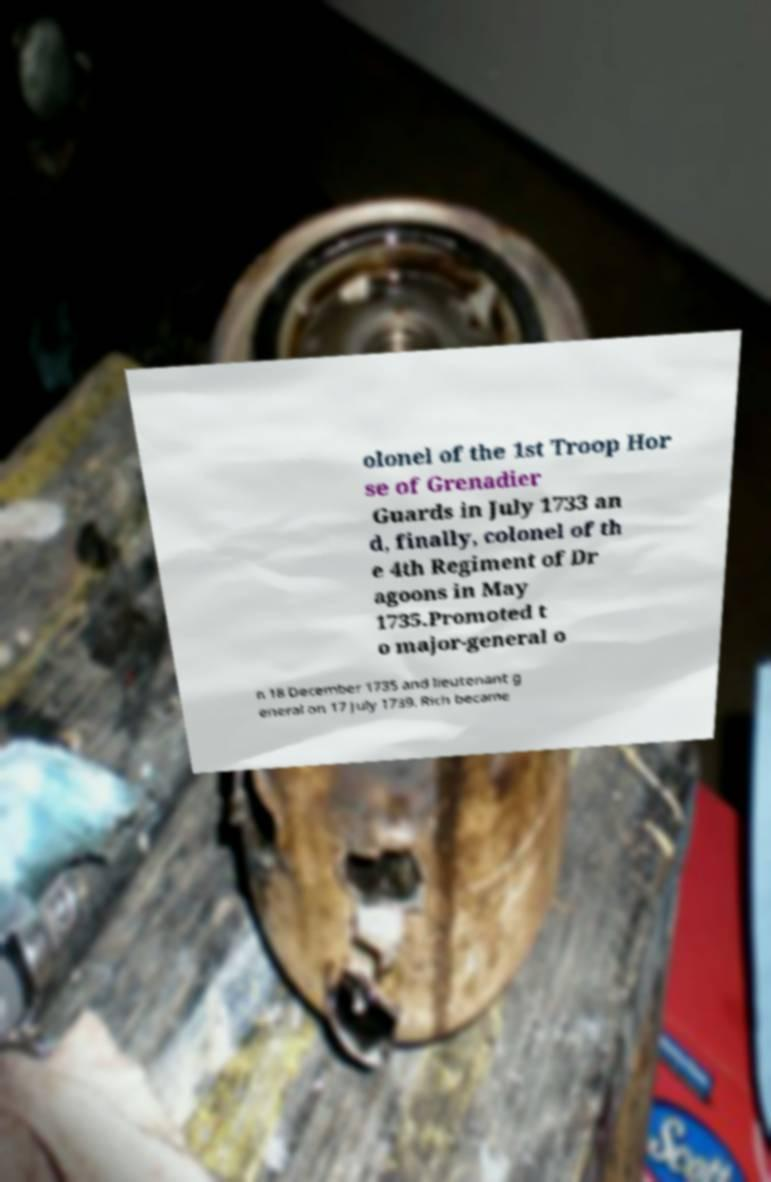Could you assist in decoding the text presented in this image and type it out clearly? olonel of the 1st Troop Hor se of Grenadier Guards in July 1733 an d, finally, colonel of th e 4th Regiment of Dr agoons in May 1735.Promoted t o major-general o n 18 December 1735 and lieutenant g eneral on 17 July 1739, Rich became 